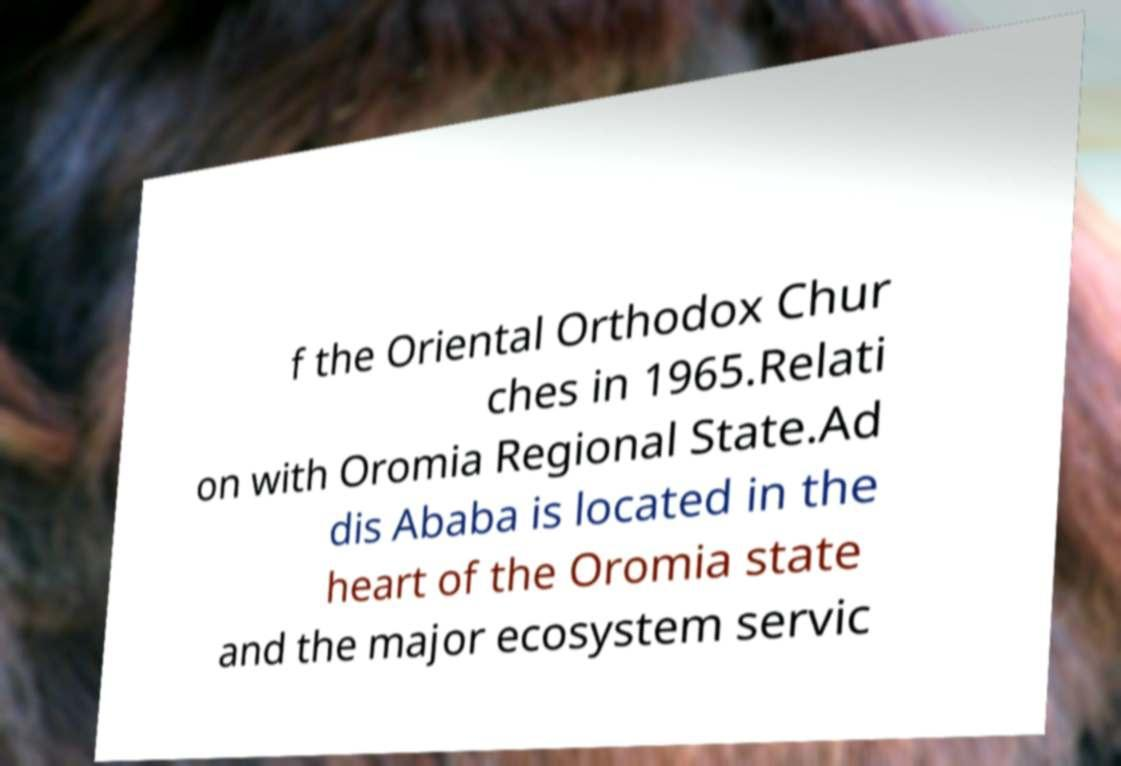Can you read and provide the text displayed in the image?This photo seems to have some interesting text. Can you extract and type it out for me? f the Oriental Orthodox Chur ches in 1965.Relati on with Oromia Regional State.Ad dis Ababa is located in the heart of the Oromia state and the major ecosystem servic 